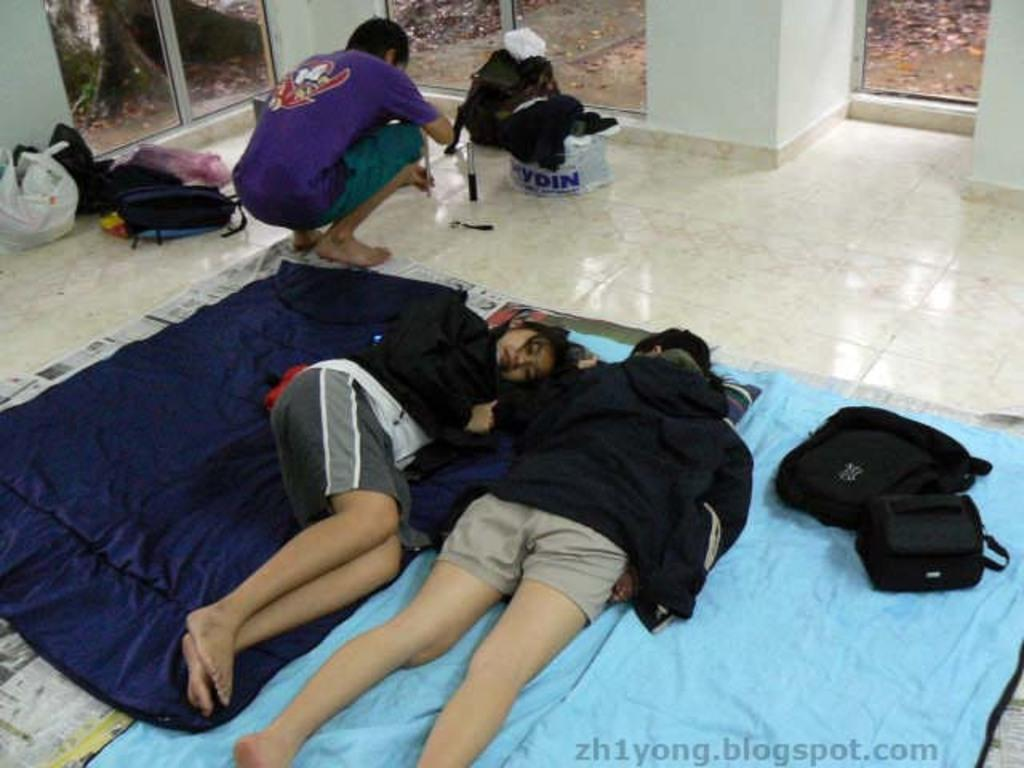Provide a one-sentence caption for the provided image. A post for zh1yong.blogspot.com showing people laying on blankets on the floor of a room. 